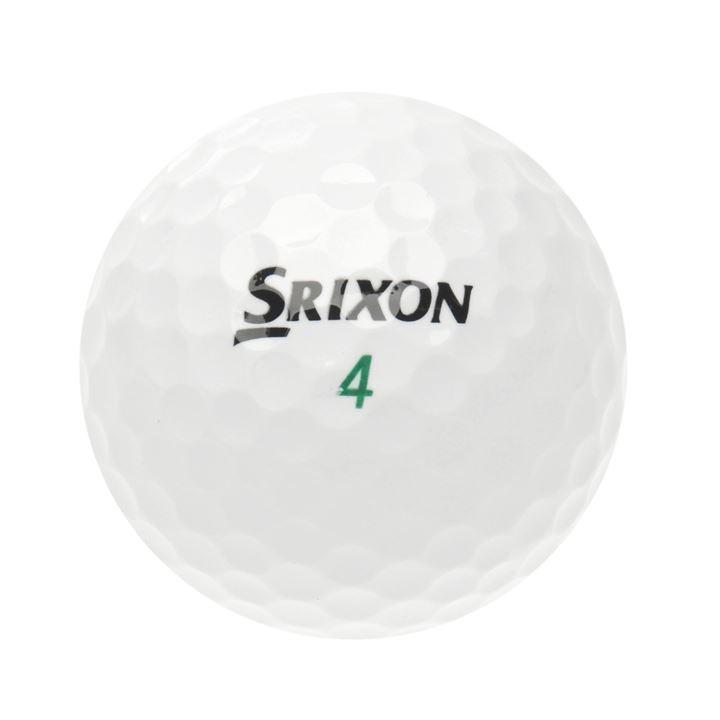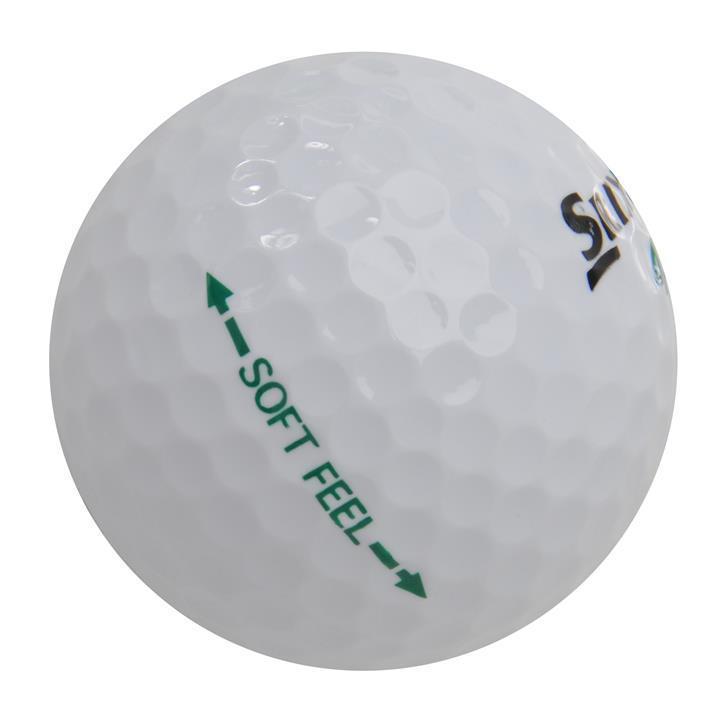The first image is the image on the left, the second image is the image on the right. Considering the images on both sides, is "The object in the image on the left is mostly green." valid? Answer yes or no. No. 